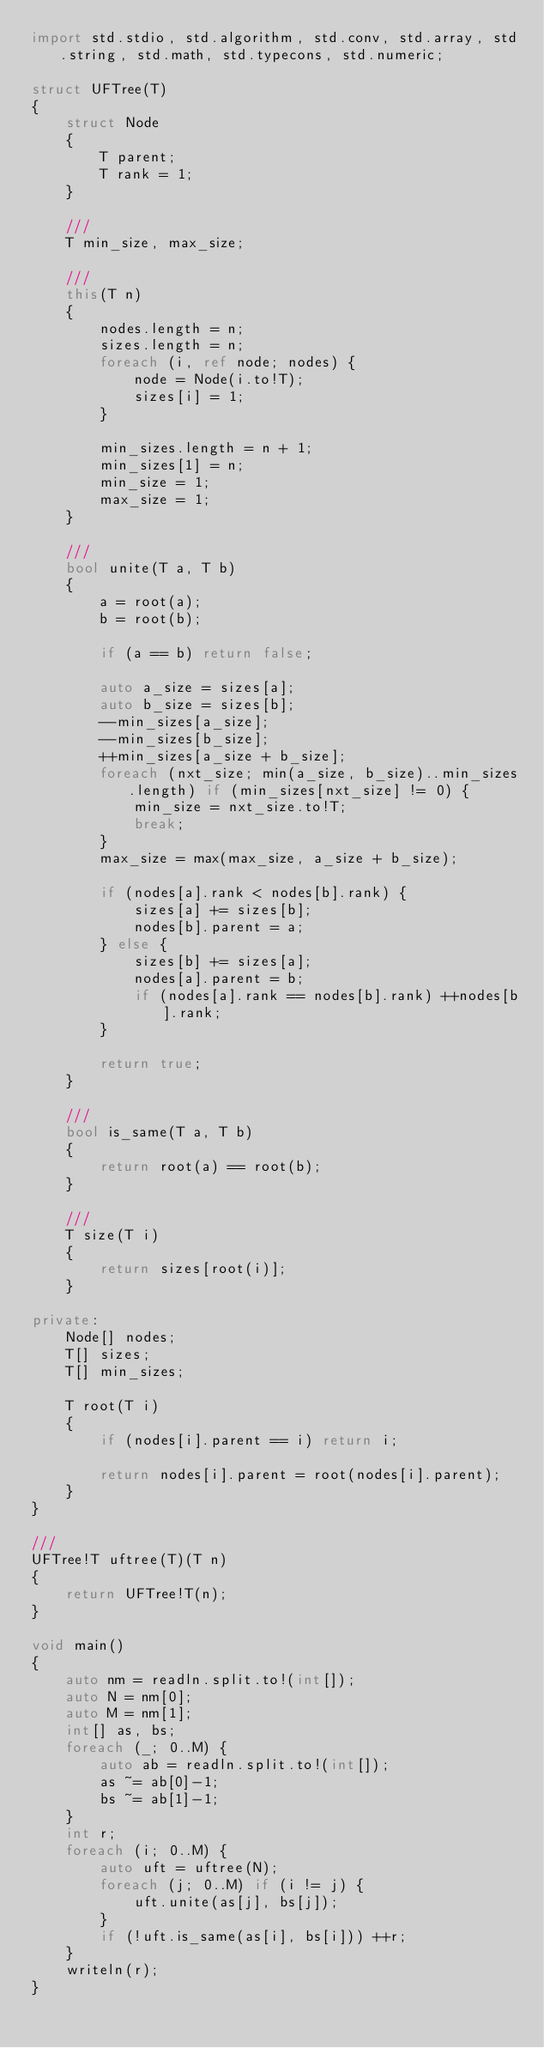Convert code to text. <code><loc_0><loc_0><loc_500><loc_500><_D_>import std.stdio, std.algorithm, std.conv, std.array, std.string, std.math, std.typecons, std.numeric;

struct UFTree(T)
{
    struct Node
    {
        T parent;
        T rank = 1;
    }

    ///
    T min_size, max_size;

    ///
    this(T n)
    {
        nodes.length = n;
        sizes.length = n;
        foreach (i, ref node; nodes) {
            node = Node(i.to!T);
            sizes[i] = 1;
        }

        min_sizes.length = n + 1;
        min_sizes[1] = n;
        min_size = 1;
        max_size = 1;
    }

    ///
    bool unite(T a, T b)
    {
        a = root(a);
        b = root(b);

        if (a == b) return false;

        auto a_size = sizes[a];
        auto b_size = sizes[b];
        --min_sizes[a_size];
        --min_sizes[b_size];
        ++min_sizes[a_size + b_size];
        foreach (nxt_size; min(a_size, b_size)..min_sizes.length) if (min_sizes[nxt_size] != 0) {
            min_size = nxt_size.to!T;
            break;
        }
        max_size = max(max_size, a_size + b_size);

        if (nodes[a].rank < nodes[b].rank) {
            sizes[a] += sizes[b];
            nodes[b].parent = a;
        } else {
            sizes[b] += sizes[a];
            nodes[a].parent = b;
            if (nodes[a].rank == nodes[b].rank) ++nodes[b].rank;
        }

        return true;
    }

    ///
    bool is_same(T a, T b)
    {
        return root(a) == root(b);
    }

    ///
    T size(T i)
    {
        return sizes[root(i)];
    }

private:
    Node[] nodes;
    T[] sizes;
    T[] min_sizes;

    T root(T i)
    {
        if (nodes[i].parent == i) return i;

        return nodes[i].parent = root(nodes[i].parent);
    }
}

///
UFTree!T uftree(T)(T n)
{
    return UFTree!T(n);
}

void main()
{
    auto nm = readln.split.to!(int[]);
    auto N = nm[0];
    auto M = nm[1];
    int[] as, bs;
    foreach (_; 0..M) {
        auto ab = readln.split.to!(int[]);
        as ~= ab[0]-1;
        bs ~= ab[1]-1;
    }
    int r;
    foreach (i; 0..M) {
        auto uft = uftree(N);
        foreach (j; 0..M) if (i != j) {
            uft.unite(as[j], bs[j]);
        }
        if (!uft.is_same(as[i], bs[i])) ++r;
    }
    writeln(r);
}</code> 